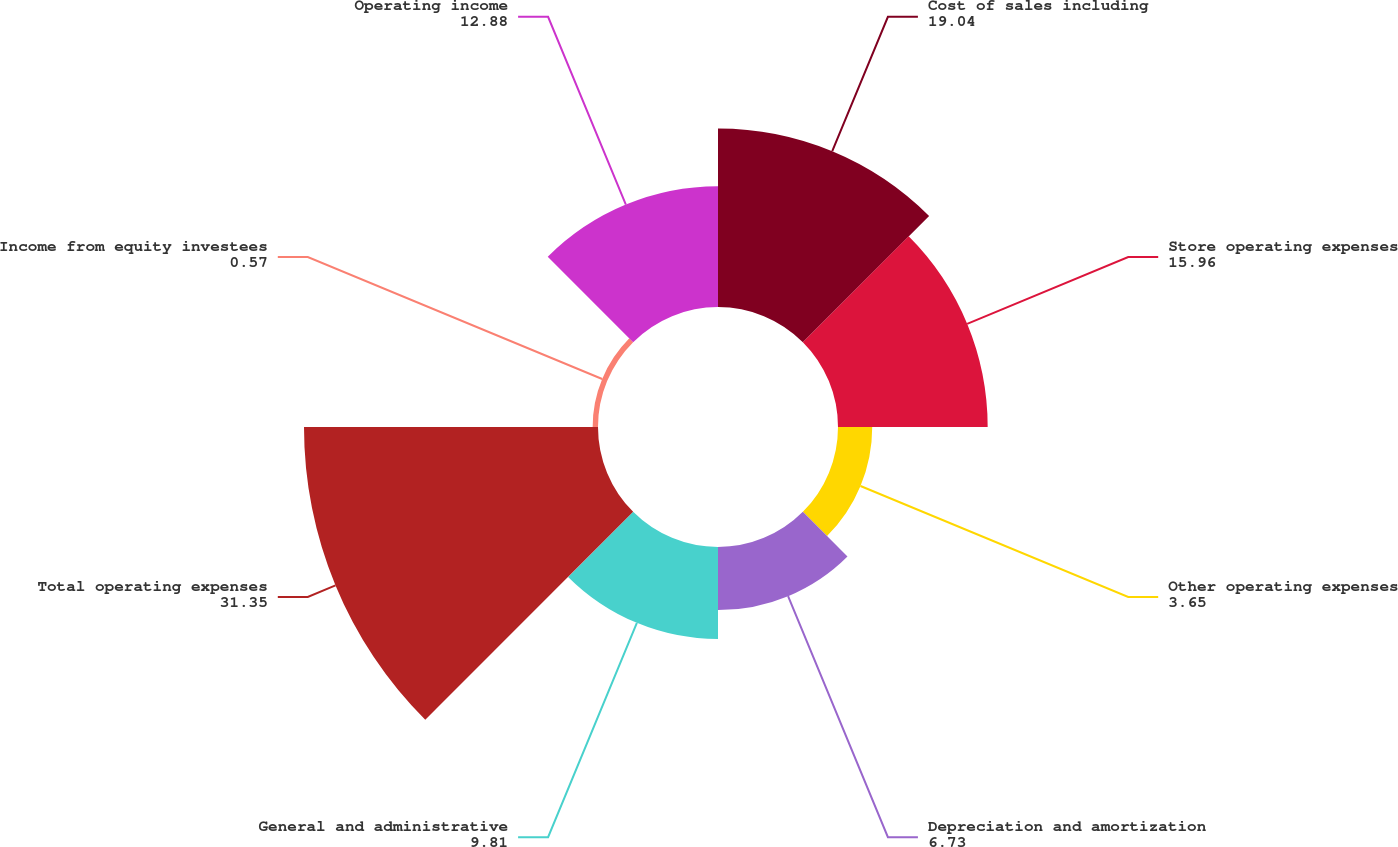Convert chart to OTSL. <chart><loc_0><loc_0><loc_500><loc_500><pie_chart><fcel>Cost of sales including<fcel>Store operating expenses<fcel>Other operating expenses<fcel>Depreciation and amortization<fcel>General and administrative<fcel>Total operating expenses<fcel>Income from equity investees<fcel>Operating income<nl><fcel>19.04%<fcel>15.96%<fcel>3.65%<fcel>6.73%<fcel>9.81%<fcel>31.35%<fcel>0.57%<fcel>12.88%<nl></chart> 